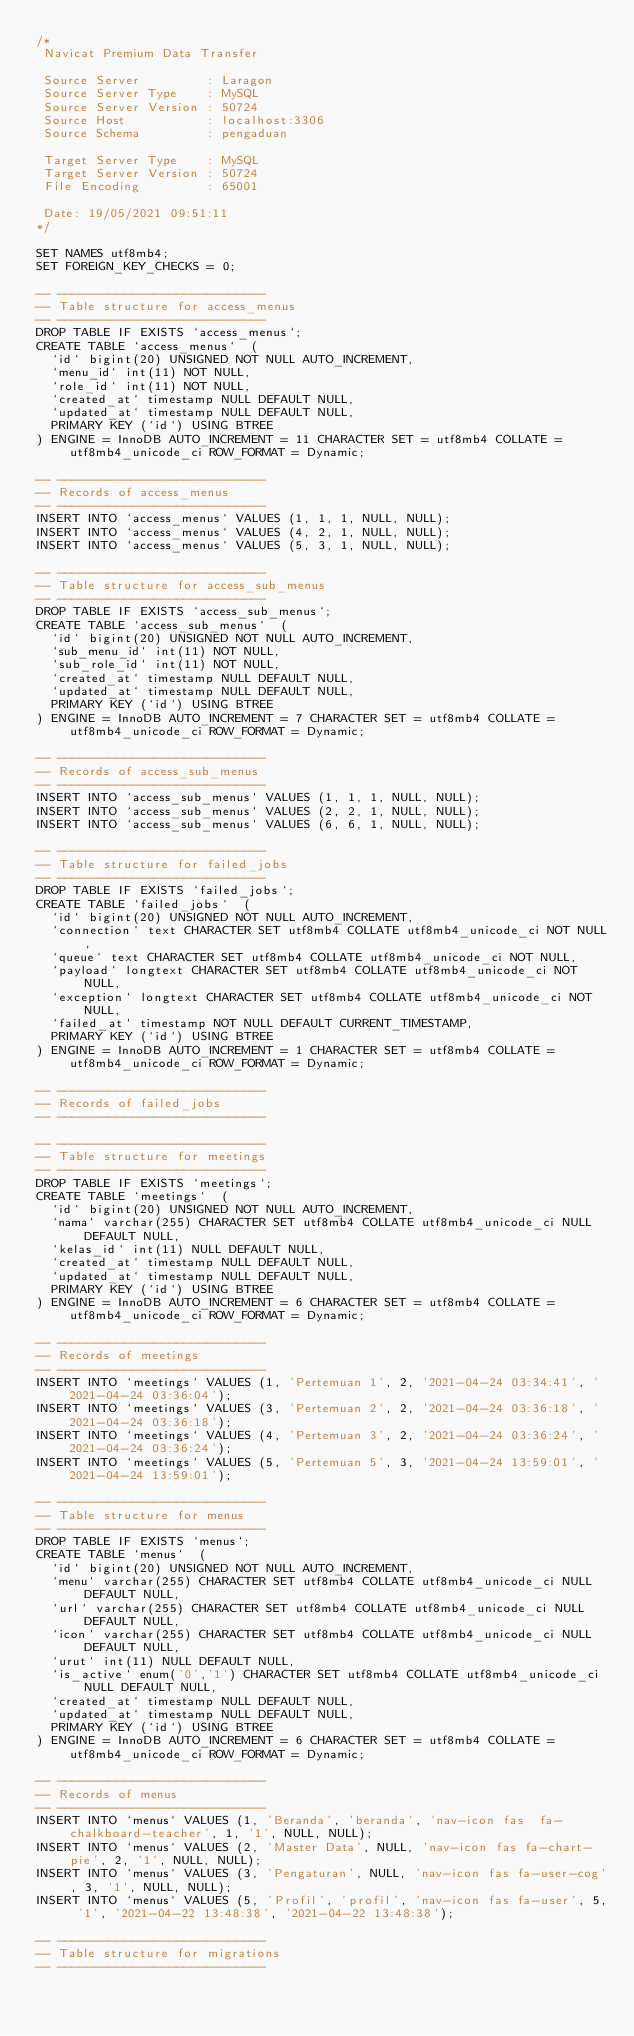<code> <loc_0><loc_0><loc_500><loc_500><_SQL_>/*
 Navicat Premium Data Transfer

 Source Server         : Laragon
 Source Server Type    : MySQL
 Source Server Version : 50724
 Source Host           : localhost:3306
 Source Schema         : pengaduan

 Target Server Type    : MySQL
 Target Server Version : 50724
 File Encoding         : 65001

 Date: 19/05/2021 09:51:11
*/

SET NAMES utf8mb4;
SET FOREIGN_KEY_CHECKS = 0;

-- ----------------------------
-- Table structure for access_menus
-- ----------------------------
DROP TABLE IF EXISTS `access_menus`;
CREATE TABLE `access_menus`  (
  `id` bigint(20) UNSIGNED NOT NULL AUTO_INCREMENT,
  `menu_id` int(11) NOT NULL,
  `role_id` int(11) NOT NULL,
  `created_at` timestamp NULL DEFAULT NULL,
  `updated_at` timestamp NULL DEFAULT NULL,
  PRIMARY KEY (`id`) USING BTREE
) ENGINE = InnoDB AUTO_INCREMENT = 11 CHARACTER SET = utf8mb4 COLLATE = utf8mb4_unicode_ci ROW_FORMAT = Dynamic;

-- ----------------------------
-- Records of access_menus
-- ----------------------------
INSERT INTO `access_menus` VALUES (1, 1, 1, NULL, NULL);
INSERT INTO `access_menus` VALUES (4, 2, 1, NULL, NULL);
INSERT INTO `access_menus` VALUES (5, 3, 1, NULL, NULL);

-- ----------------------------
-- Table structure for access_sub_menus
-- ----------------------------
DROP TABLE IF EXISTS `access_sub_menus`;
CREATE TABLE `access_sub_menus`  (
  `id` bigint(20) UNSIGNED NOT NULL AUTO_INCREMENT,
  `sub_menu_id` int(11) NOT NULL,
  `sub_role_id` int(11) NOT NULL,
  `created_at` timestamp NULL DEFAULT NULL,
  `updated_at` timestamp NULL DEFAULT NULL,
  PRIMARY KEY (`id`) USING BTREE
) ENGINE = InnoDB AUTO_INCREMENT = 7 CHARACTER SET = utf8mb4 COLLATE = utf8mb4_unicode_ci ROW_FORMAT = Dynamic;

-- ----------------------------
-- Records of access_sub_menus
-- ----------------------------
INSERT INTO `access_sub_menus` VALUES (1, 1, 1, NULL, NULL);
INSERT INTO `access_sub_menus` VALUES (2, 2, 1, NULL, NULL);
INSERT INTO `access_sub_menus` VALUES (6, 6, 1, NULL, NULL);

-- ----------------------------
-- Table structure for failed_jobs
-- ----------------------------
DROP TABLE IF EXISTS `failed_jobs`;
CREATE TABLE `failed_jobs`  (
  `id` bigint(20) UNSIGNED NOT NULL AUTO_INCREMENT,
  `connection` text CHARACTER SET utf8mb4 COLLATE utf8mb4_unicode_ci NOT NULL,
  `queue` text CHARACTER SET utf8mb4 COLLATE utf8mb4_unicode_ci NOT NULL,
  `payload` longtext CHARACTER SET utf8mb4 COLLATE utf8mb4_unicode_ci NOT NULL,
  `exception` longtext CHARACTER SET utf8mb4 COLLATE utf8mb4_unicode_ci NOT NULL,
  `failed_at` timestamp NOT NULL DEFAULT CURRENT_TIMESTAMP,
  PRIMARY KEY (`id`) USING BTREE
) ENGINE = InnoDB AUTO_INCREMENT = 1 CHARACTER SET = utf8mb4 COLLATE = utf8mb4_unicode_ci ROW_FORMAT = Dynamic;

-- ----------------------------
-- Records of failed_jobs
-- ----------------------------

-- ----------------------------
-- Table structure for meetings
-- ----------------------------
DROP TABLE IF EXISTS `meetings`;
CREATE TABLE `meetings`  (
  `id` bigint(20) UNSIGNED NOT NULL AUTO_INCREMENT,
  `nama` varchar(255) CHARACTER SET utf8mb4 COLLATE utf8mb4_unicode_ci NULL DEFAULT NULL,
  `kelas_id` int(11) NULL DEFAULT NULL,
  `created_at` timestamp NULL DEFAULT NULL,
  `updated_at` timestamp NULL DEFAULT NULL,
  PRIMARY KEY (`id`) USING BTREE
) ENGINE = InnoDB AUTO_INCREMENT = 6 CHARACTER SET = utf8mb4 COLLATE = utf8mb4_unicode_ci ROW_FORMAT = Dynamic;

-- ----------------------------
-- Records of meetings
-- ----------------------------
INSERT INTO `meetings` VALUES (1, 'Pertemuan 1', 2, '2021-04-24 03:34:41', '2021-04-24 03:36:04');
INSERT INTO `meetings` VALUES (3, 'Pertemuan 2', 2, '2021-04-24 03:36:18', '2021-04-24 03:36:18');
INSERT INTO `meetings` VALUES (4, 'Pertemuan 3', 2, '2021-04-24 03:36:24', '2021-04-24 03:36:24');
INSERT INTO `meetings` VALUES (5, 'Pertemuan 5', 3, '2021-04-24 13:59:01', '2021-04-24 13:59:01');

-- ----------------------------
-- Table structure for menus
-- ----------------------------
DROP TABLE IF EXISTS `menus`;
CREATE TABLE `menus`  (
  `id` bigint(20) UNSIGNED NOT NULL AUTO_INCREMENT,
  `menu` varchar(255) CHARACTER SET utf8mb4 COLLATE utf8mb4_unicode_ci NULL DEFAULT NULL,
  `url` varchar(255) CHARACTER SET utf8mb4 COLLATE utf8mb4_unicode_ci NULL DEFAULT NULL,
  `icon` varchar(255) CHARACTER SET utf8mb4 COLLATE utf8mb4_unicode_ci NULL DEFAULT NULL,
  `urut` int(11) NULL DEFAULT NULL,
  `is_active` enum('0','1') CHARACTER SET utf8mb4 COLLATE utf8mb4_unicode_ci NULL DEFAULT NULL,
  `created_at` timestamp NULL DEFAULT NULL,
  `updated_at` timestamp NULL DEFAULT NULL,
  PRIMARY KEY (`id`) USING BTREE
) ENGINE = InnoDB AUTO_INCREMENT = 6 CHARACTER SET = utf8mb4 COLLATE = utf8mb4_unicode_ci ROW_FORMAT = Dynamic;

-- ----------------------------
-- Records of menus
-- ----------------------------
INSERT INTO `menus` VALUES (1, 'Beranda', 'beranda', 'nav-icon fas  fa-chalkboard-teacher', 1, '1', NULL, NULL);
INSERT INTO `menus` VALUES (2, 'Master Data', NULL, 'nav-icon fas fa-chart-pie', 2, '1', NULL, NULL);
INSERT INTO `menus` VALUES (3, 'Pengaturan', NULL, 'nav-icon fas fa-user-cog', 3, '1', NULL, NULL);
INSERT INTO `menus` VALUES (5, 'Profil', 'profil', 'nav-icon fas fa-user', 5, '1', '2021-04-22 13:48:38', '2021-04-22 13:48:38');

-- ----------------------------
-- Table structure for migrations
-- ----------------------------</code> 